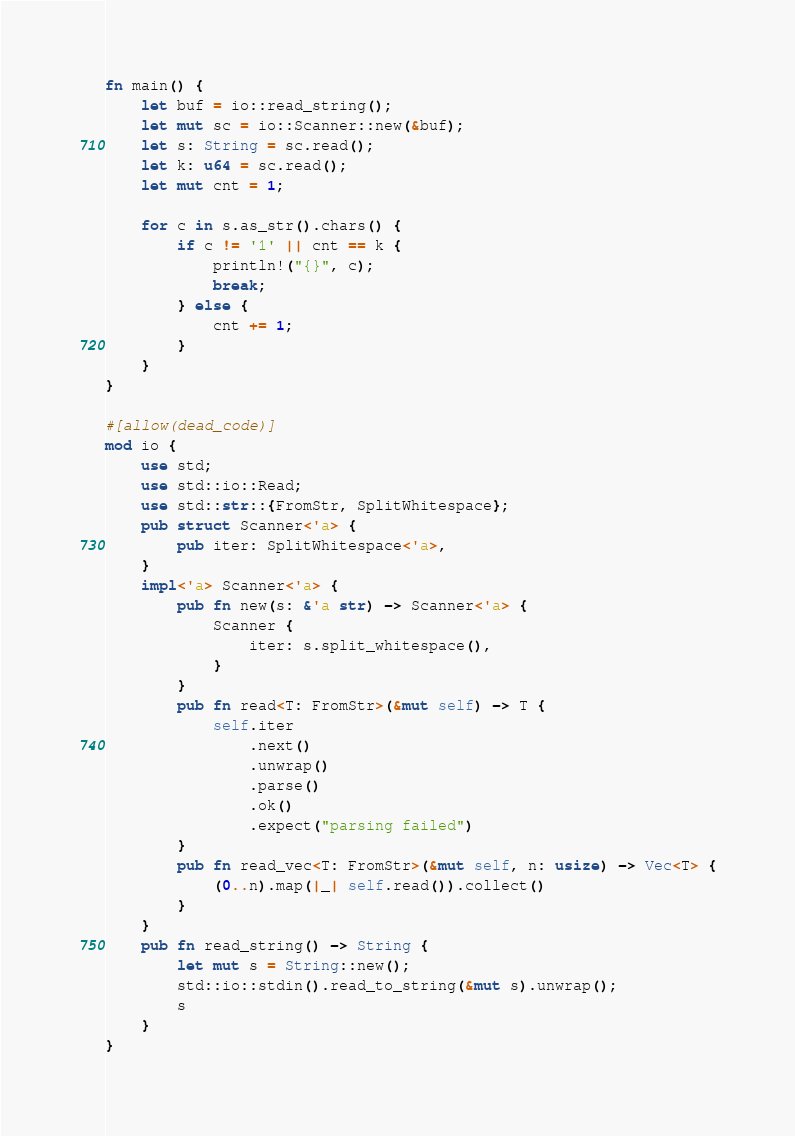Convert code to text. <code><loc_0><loc_0><loc_500><loc_500><_Rust_>fn main() {
    let buf = io::read_string();
    let mut sc = io::Scanner::new(&buf);
    let s: String = sc.read();
    let k: u64 = sc.read();
    let mut cnt = 1;

    for c in s.as_str().chars() {
        if c != '1' || cnt == k {
            println!("{}", c);
            break;
        } else {
            cnt += 1;
        }
    }
}

#[allow(dead_code)]
mod io {
    use std;
    use std::io::Read;
    use std::str::{FromStr, SplitWhitespace};
    pub struct Scanner<'a> {
        pub iter: SplitWhitespace<'a>,
    }
    impl<'a> Scanner<'a> {
        pub fn new(s: &'a str) -> Scanner<'a> {
            Scanner {
                iter: s.split_whitespace(),
            }
        }
        pub fn read<T: FromStr>(&mut self) -> T {
            self.iter
                .next()
                .unwrap()
                .parse()
                .ok()
                .expect("parsing failed")
        }
        pub fn read_vec<T: FromStr>(&mut self, n: usize) -> Vec<T> {
            (0..n).map(|_| self.read()).collect()
        }
    }
    pub fn read_string() -> String {
        let mut s = String::new();
        std::io::stdin().read_to_string(&mut s).unwrap();
        s
    }
}
</code> 